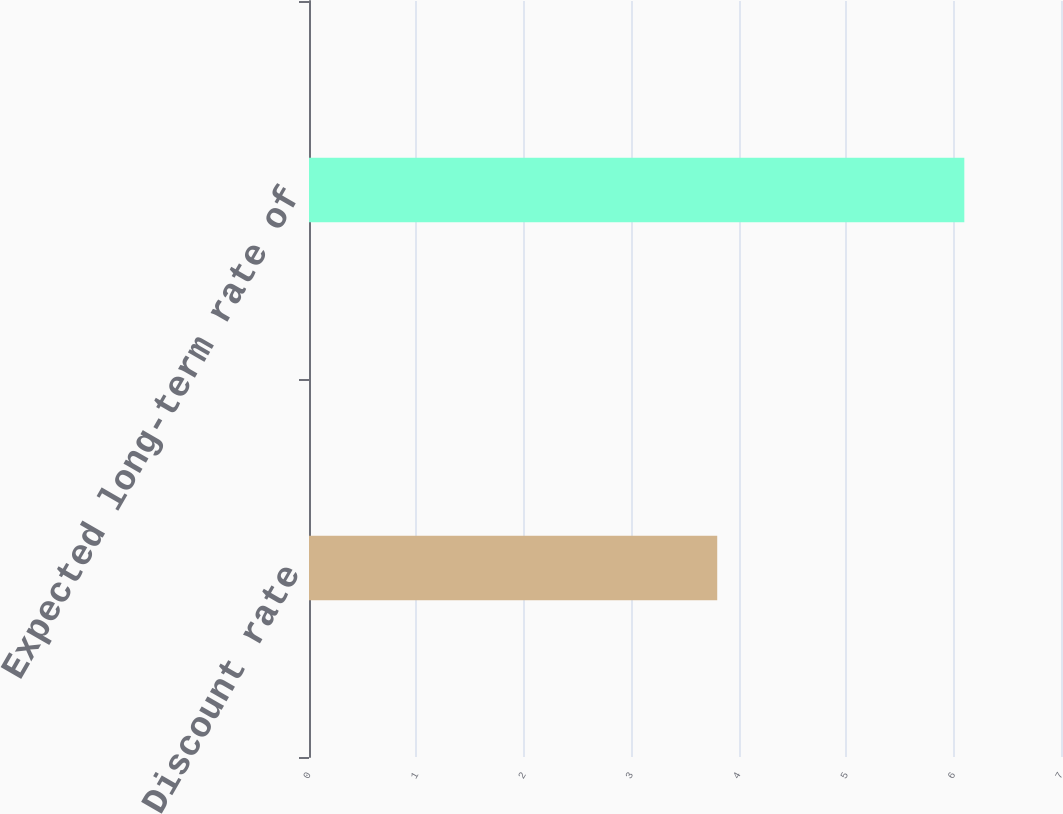Convert chart. <chart><loc_0><loc_0><loc_500><loc_500><bar_chart><fcel>Discount rate<fcel>Expected long-term rate of<nl><fcel>3.8<fcel>6.1<nl></chart> 